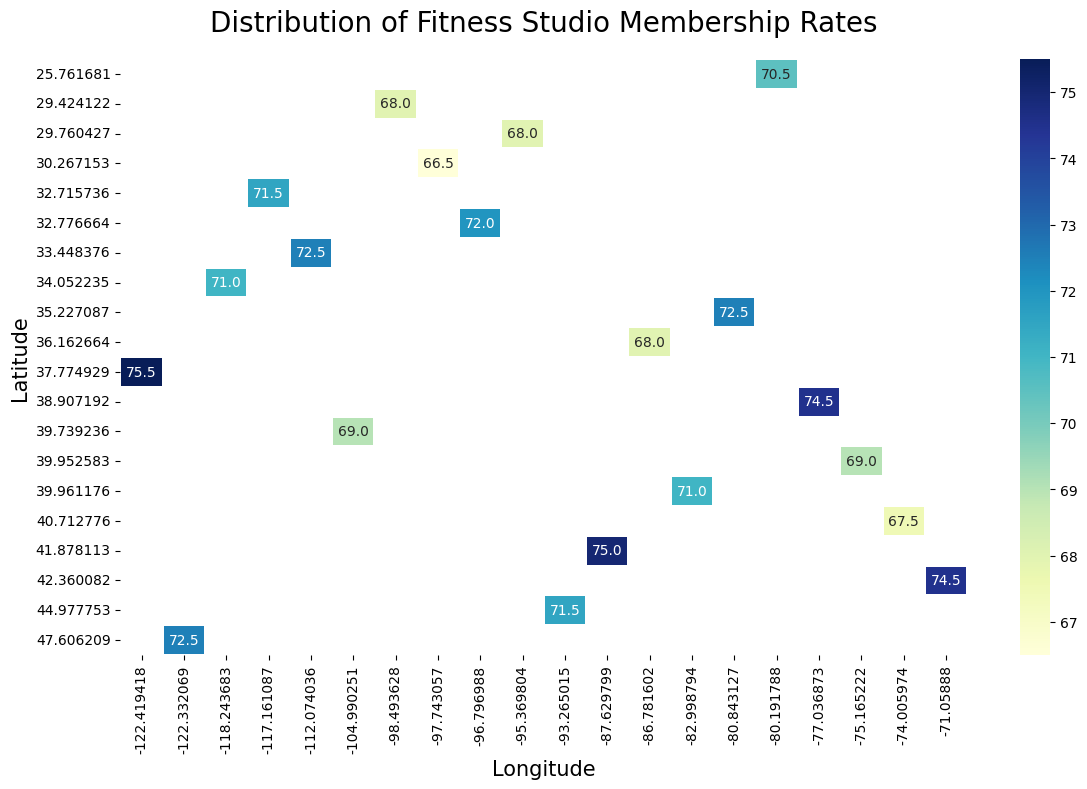What is the highest membership rate in Urban areas? First, look for the highest number displayed on the heatmap for locations classified as Urban. The maximum number shown is 86, at the coordinates corresponding to latitude 37.774929 and longitude -122.419418.
Answer: 86 How does the average membership rate in Rural areas compare to that in Urban areas? Calculate the average membership rate for both Rural and Urban areas. For Rural areas, add up all the membership rates and divide by the number of entries; do the same for Urban areas. The average for Rural is approximately 61.45, while for Urban is approximately 80.05. By comparing these two, Rural areas have a significantly lower average membership rate.
Answer: Rural: 61.45, Urban: 80.05 Which latitude has the most variation in membership rates? Examine the heatmap for the latitude with the widest range of values. Latitude 40.712776 has values that range from 60 (Rural) to 75 (Urban), showing significant variation.
Answer: 40.712776 Is there a pattern in the membership rates based on the longitude? Assess the visual distribution of colors along the longitude axis. Generally, there is no obvious color gradient or clustering that indicates a specific pattern based on longitude in the entire dataset.
Answer: No clear pattern Which area types have more fitness studios located at high latitudes (above 40)? Identify latitudes above 40 and count the number of fitness studio markers for Urban and Rural types. Urban areas have more studios located at higher latitudes than Rural areas.
Answer: Urban What is the difference between the highest and lowest membership rates in Rural areas? Locate the highest and lowest membership rates in the heatmap for Rural areas. The highest rate is 65, and the lowest is 58. Subtract these two values to find the difference: 65 - 58.
Answer: 7 Which region (latitude and longitude) has the most expensive membership rate? Scan the heatmap to identify the location with the darkest color/intensity, indicating the highest rate. The region around latitude 37.774929 and longitude -122.419418 shows the highest rate of 86.
Answer: Latitude 37.774929, Longitude -122.419418 At which latitude is there the least variation in membership rates for Urban areas? Find a latitude where the color variance (intensity change) is minimal for locations classified as Urban. Latitude 39.739236 has consistent membership rates at both ends of the longitude spectrum with minimal variation (77 in multiple locations).
Answer: 39.739236 Compare the membership rate at latitude 33.448376 for Urban and Rural areas. Look at the heatmap for the specified latitude. The Urban rate is 82, and the Rural rate is 63.
Answer: Urban: 82, Rural: 63 